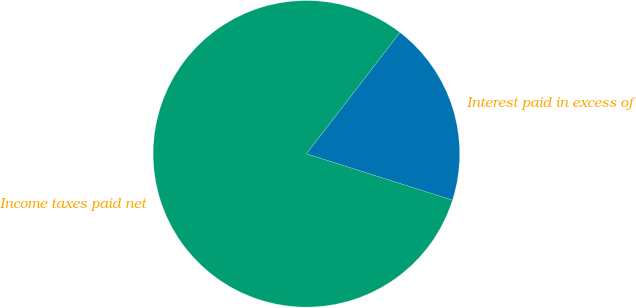Convert chart. <chart><loc_0><loc_0><loc_500><loc_500><pie_chart><fcel>Interest paid in excess of<fcel>Income taxes paid net<nl><fcel>19.44%<fcel>80.56%<nl></chart> 